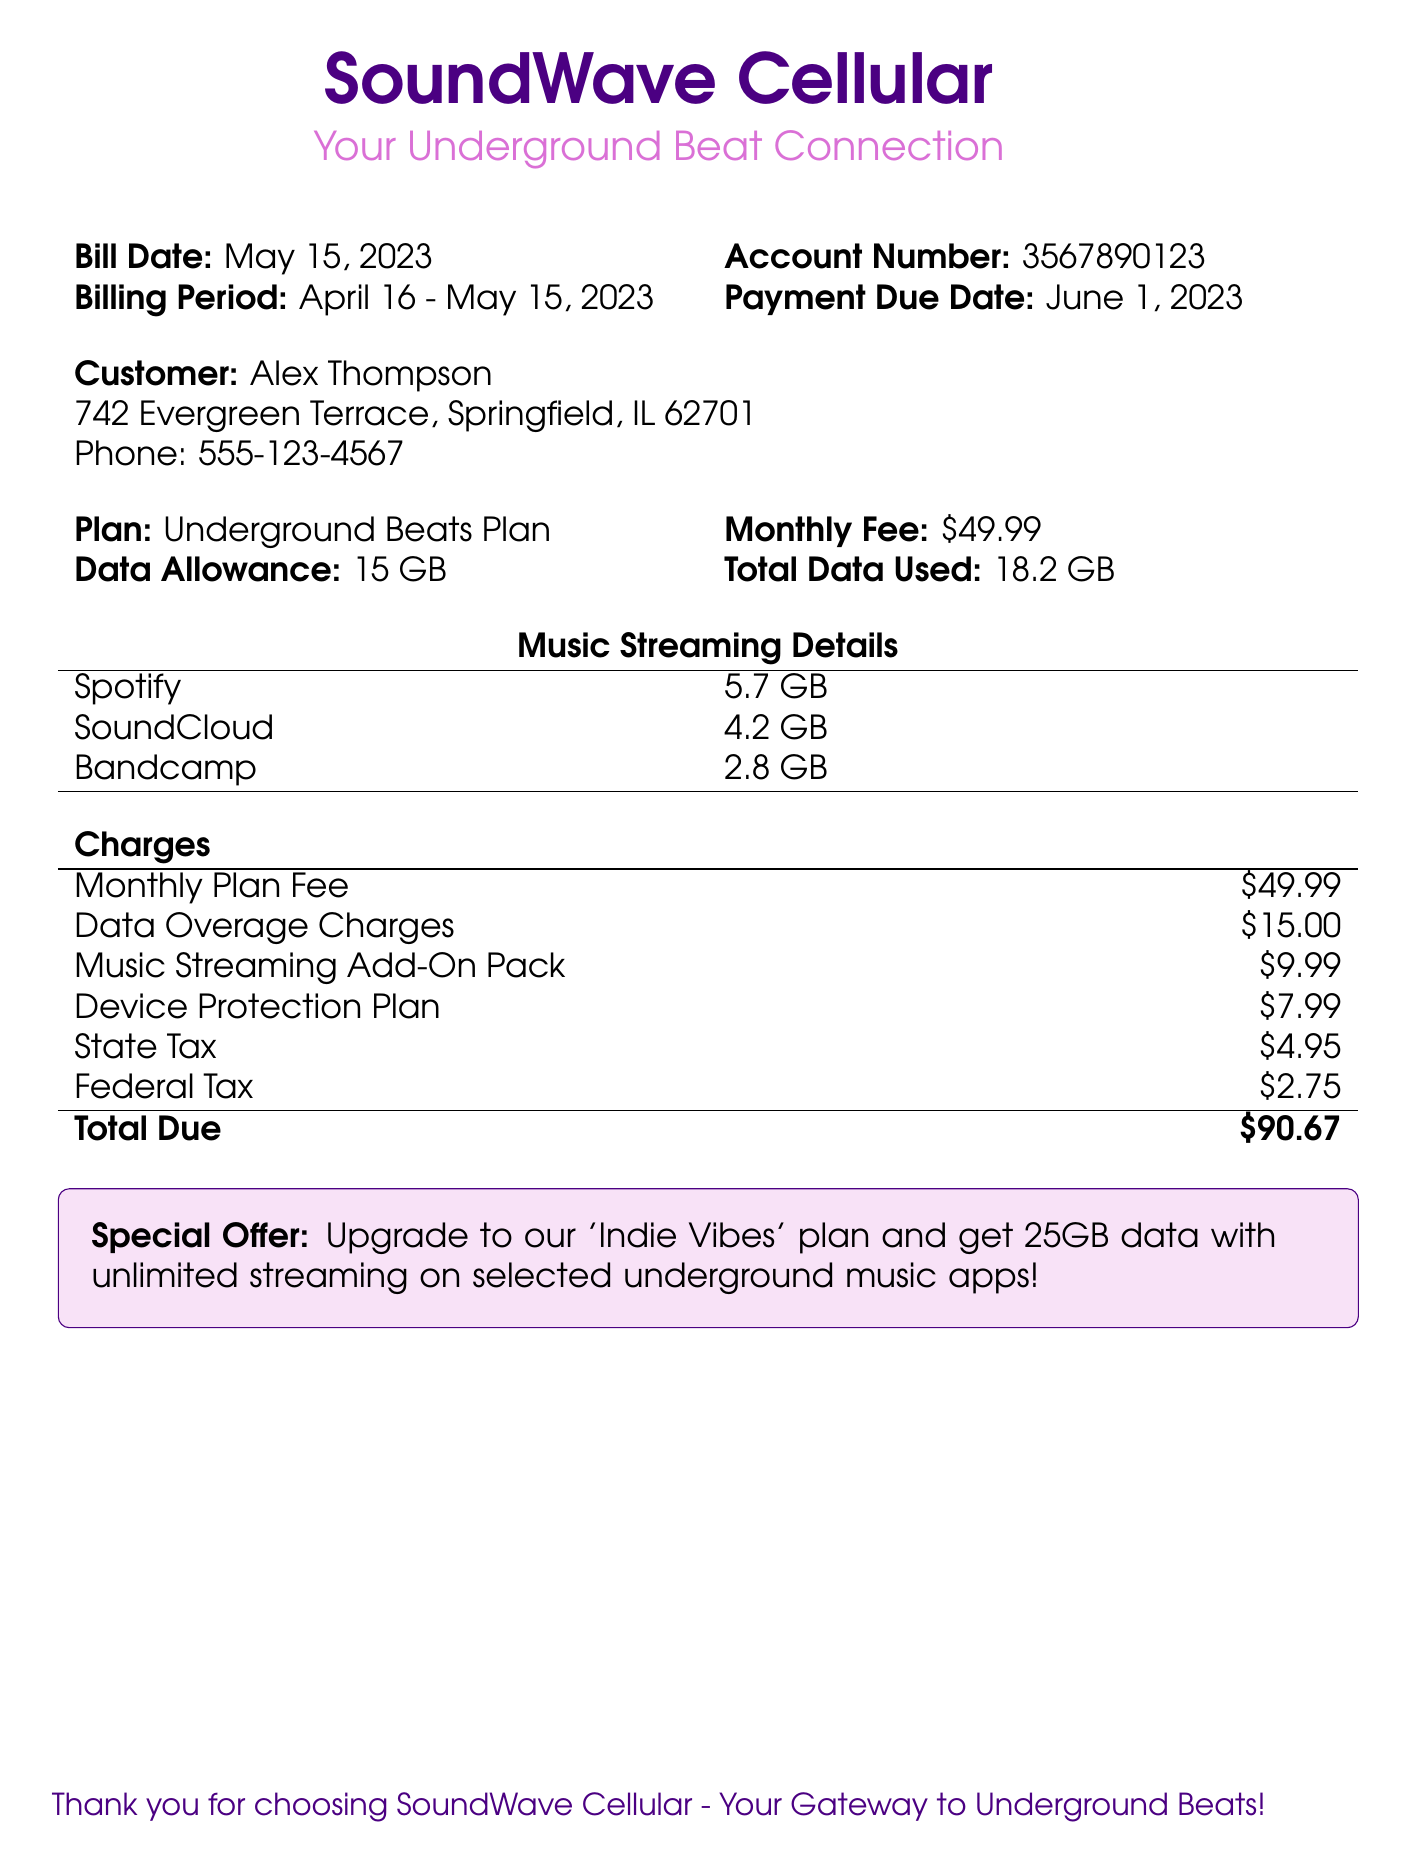What is the bill date? The bill date listed in the document is the day it was issued, which is May 15, 2023.
Answer: May 15, 2023 Who is the customer? The document specifies the individual receiving the bill as Alex Thompson.
Answer: Alex Thompson What is the monthly fee for the plan? The monthly fee is directly stated in the document under the plan details, which is $49.99.
Answer: $49.99 How much data has been used? The document indicates that the total data used is 18.2 GB, which is more than the allowance.
Answer: 18.2 GB What are the data overage charges? The document specifies the costs incurred due to exceeding data limits, which is $15.00.
Answer: $15.00 What is included in the Music Streaming Details section? The section lists the data usage for three platforms: Spotify, SoundCloud, and Bandcamp.
Answer: Spotify, SoundCloud, Bandcamp What is the total amount due? The document summarizes all charges and states that the total amount due is $90.67.
Answer: $90.67 What is the special offer mentioned in the document? The special offer provides details about an 'Indie Vibes' plan that offers additional benefits over the current plan.
Answer: Upgrade to 'Indie Vibes' plan How much is the state tax listed? The state tax charge is specifically mentioned in the bill, which totals $4.95.
Answer: $4.95 What is the data allowance of the plan? The document specifies that the data allowance included in the plan is 15 GB.
Answer: 15 GB 